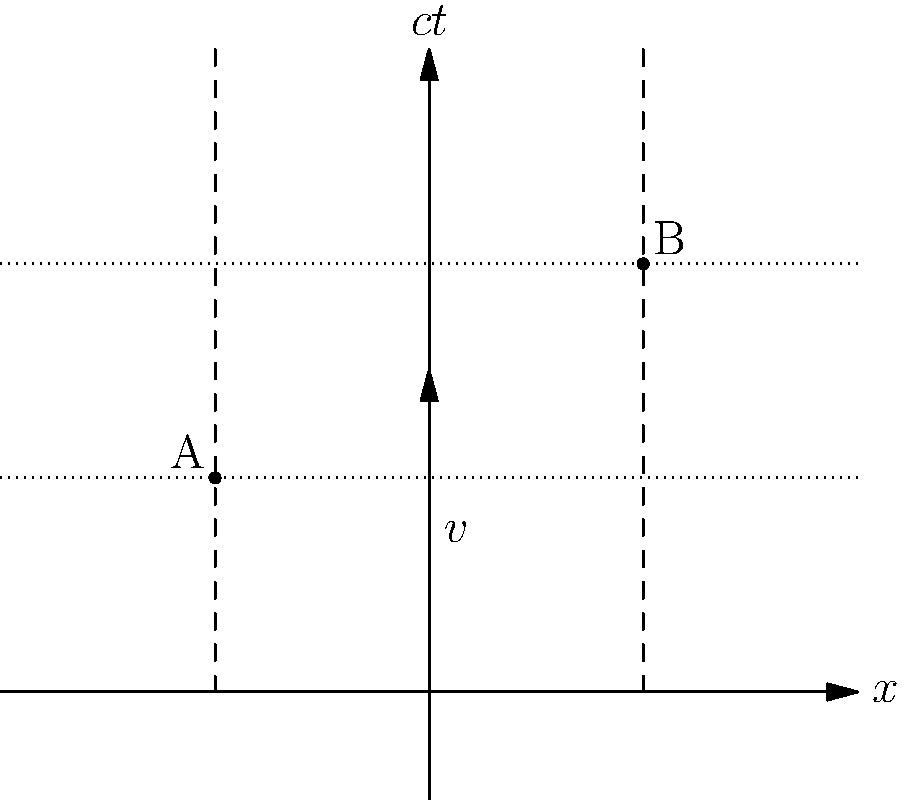In Einstein's famous thought experiment involving a train and lightning strikes, consider the spacetime diagram above. Two lightning strikes occur at events A and B. An observer on the ground sees these events as simultaneous, while an observer on a train moving with velocity $v$ relative to the ground does not. Using the diagram and your knowledge of special relativity, explain why the events are not simultaneous for the moving observer and determine the direction of the train's motion. To understand why the events are not simultaneous for the moving observer and determine the direction of the train's motion, let's analyze the spacetime diagram step-by-step:

1. The x-axis represents space, and the ct-axis represents time multiplied by the speed of light (c).

2. Events A and B are represented by two points on the diagram, occurring at different locations (x1 and x2) but at the same time t1 for the ground observer.

3. The dotted horizontal line connecting A and B represents the simultaneous occurence of these events in the ground observer's frame.

4. The dashed vertical lines represent the worldlines of the two locations where the lightning strikes occur.

5. The arrow labeled v represents the velocity of the train relative to the ground.

6. For the moving observer (on the train), their time axis is tilted in the direction of motion. This is due to the Lorentz transformation, a key aspect of special relativity.

7. The moving observer's simultaneous events would be represented by a line parallel to their tilted time axis.

8. Since the train is moving to the right (positive x-direction), the moving observer's tilted time axis will intersect event B before event A.

9. This means that in the train's frame of reference, event B occurs before event A, breaking the simultaneity observed in the ground frame.

The reason for this loss of simultaneity is the relativity of simultaneity, a consequence of the finite and constant speed of light in all reference frames, as postulated by Einstein's special relativity.

The direction of the train's motion can be determined from the diagram: the velocity arrow points in the positive x-direction, indicating that the train is moving to the right.
Answer: Events not simultaneous due to relativity of simultaneity; train moving right (positive x-direction). 